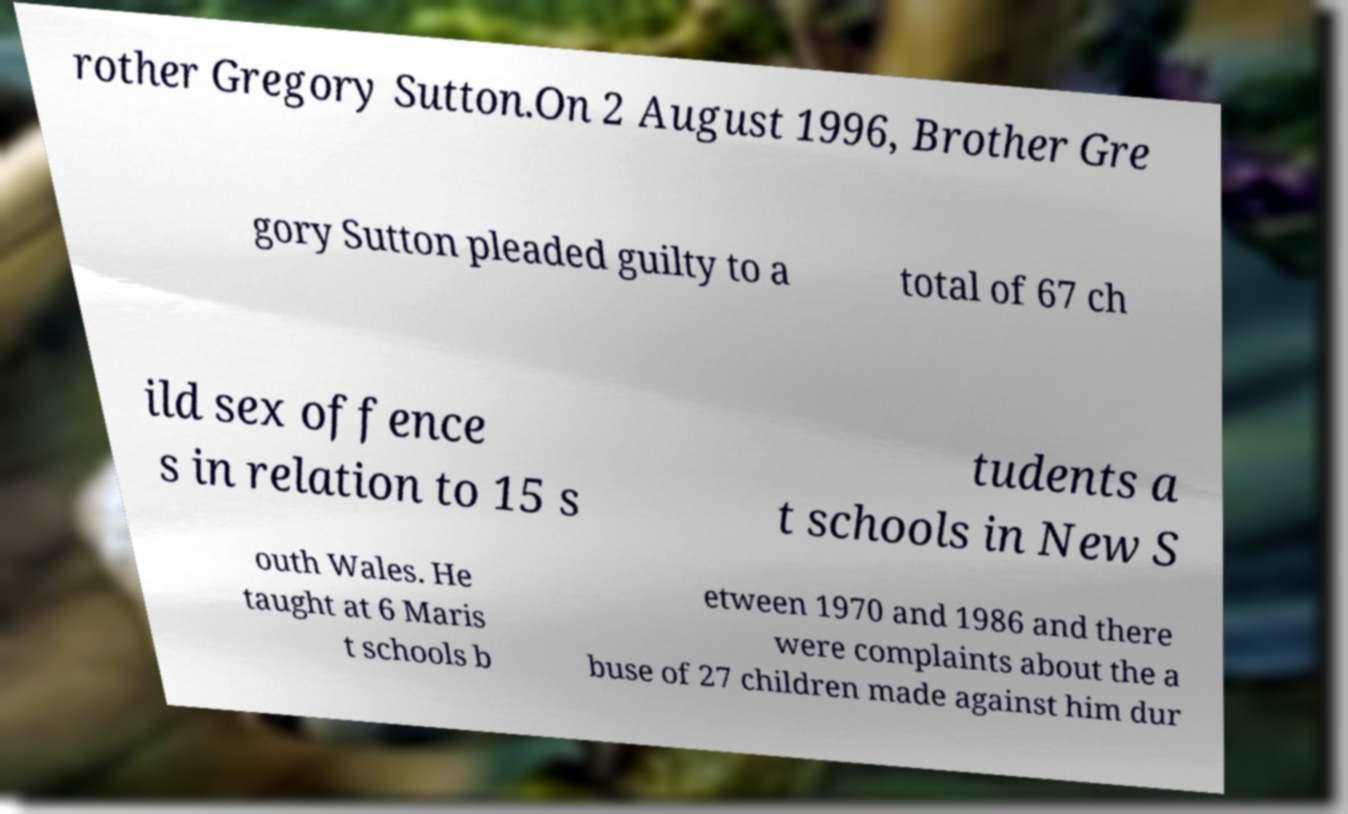Can you accurately transcribe the text from the provided image for me? rother Gregory Sutton.On 2 August 1996, Brother Gre gory Sutton pleaded guilty to a total of 67 ch ild sex offence s in relation to 15 s tudents a t schools in New S outh Wales. He taught at 6 Maris t schools b etween 1970 and 1986 and there were complaints about the a buse of 27 children made against him dur 